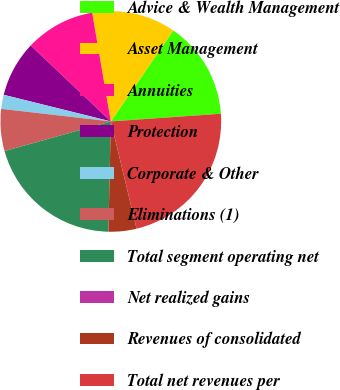Convert chart. <chart><loc_0><loc_0><loc_500><loc_500><pie_chart><fcel>Advice & Wealth Management<fcel>Asset Management<fcel>Annuities<fcel>Protection<fcel>Corporate & Other<fcel>Eliminations (1)<fcel>Total segment operating net<fcel>Net realized gains<fcel>Revenues of consolidated<fcel>Total net revenues per<nl><fcel>14.32%<fcel>12.28%<fcel>10.23%<fcel>8.19%<fcel>2.06%<fcel>6.15%<fcel>20.31%<fcel>0.01%<fcel>4.1%<fcel>22.35%<nl></chart> 